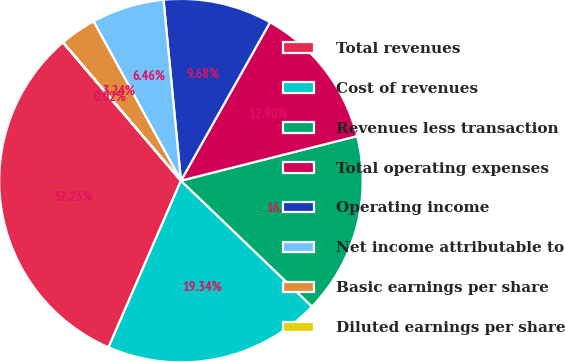Convert chart to OTSL. <chart><loc_0><loc_0><loc_500><loc_500><pie_chart><fcel>Total revenues<fcel>Cost of revenues<fcel>Revenues less transaction<fcel>Total operating expenses<fcel>Operating income<fcel>Net income attributable to<fcel>Basic earnings per share<fcel>Diluted earnings per share<nl><fcel>32.22%<fcel>19.34%<fcel>16.12%<fcel>12.9%<fcel>9.68%<fcel>6.46%<fcel>3.24%<fcel>0.02%<nl></chart> 